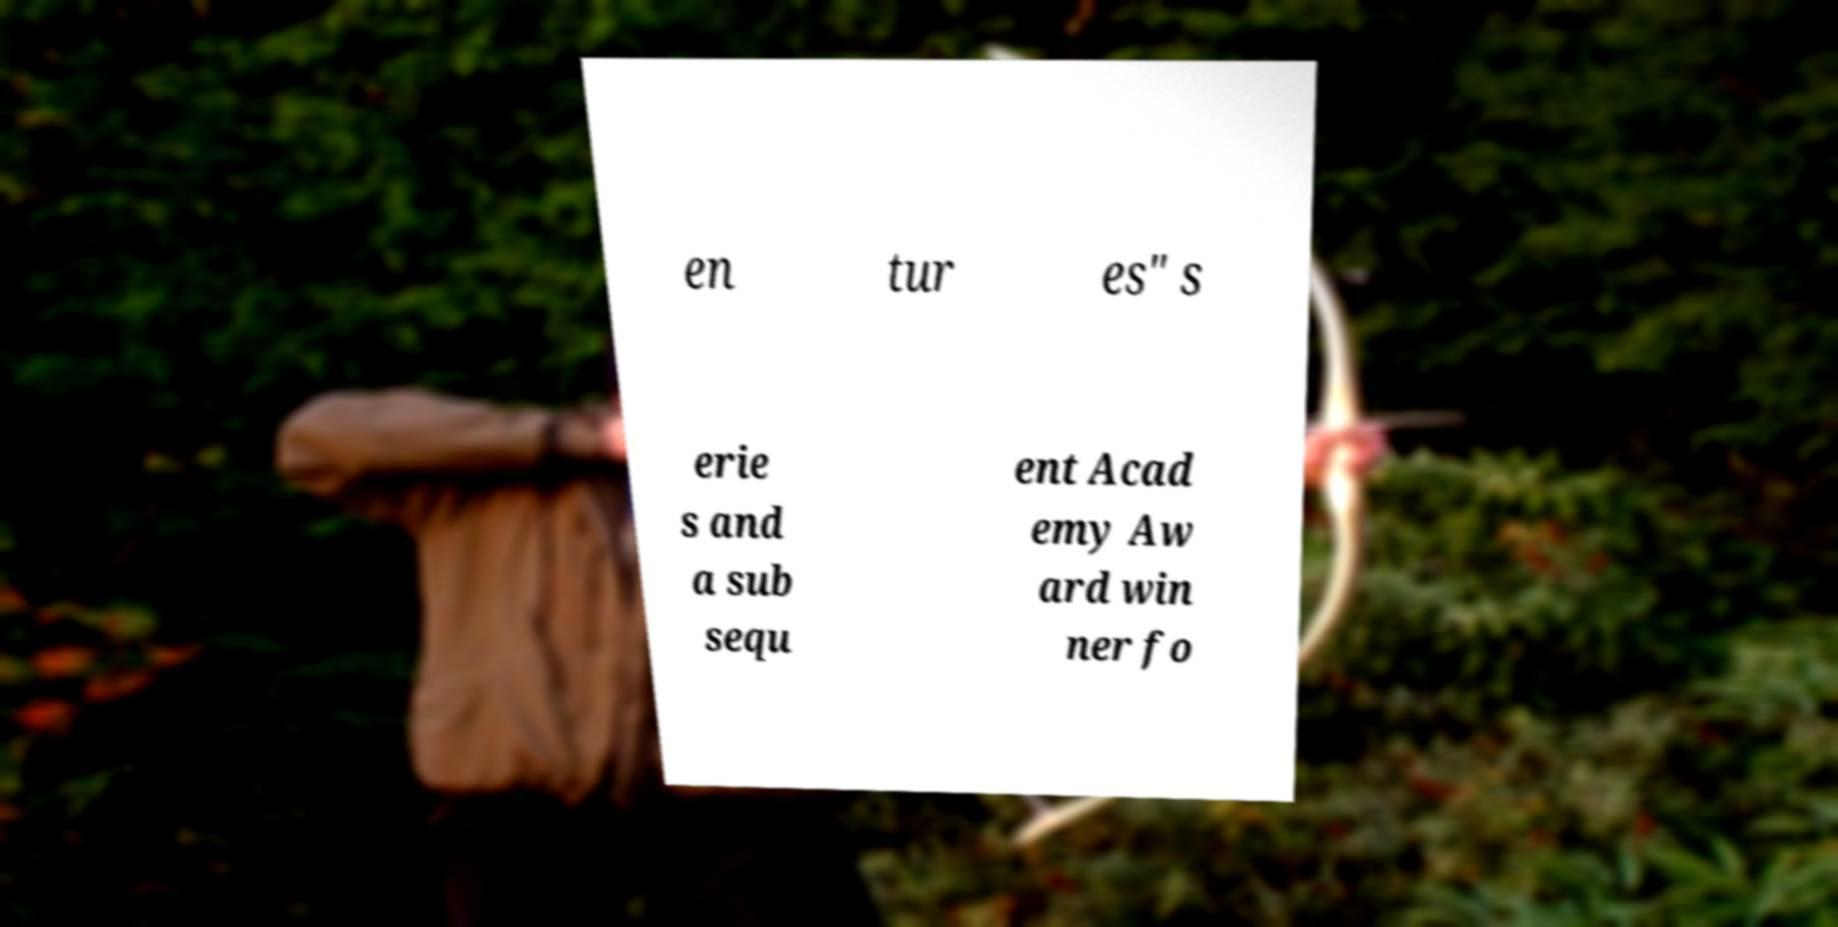Please read and relay the text visible in this image. What does it say? en tur es" s erie s and a sub sequ ent Acad emy Aw ard win ner fo 